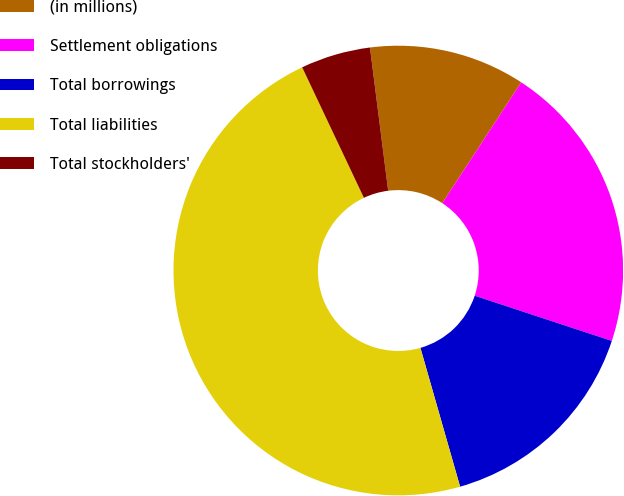Convert chart. <chart><loc_0><loc_0><loc_500><loc_500><pie_chart><fcel>(in millions)<fcel>Settlement obligations<fcel>Total borrowings<fcel>Total liabilities<fcel>Total stockholders'<nl><fcel>11.22%<fcel>20.86%<fcel>15.5%<fcel>47.4%<fcel>5.02%<nl></chart> 